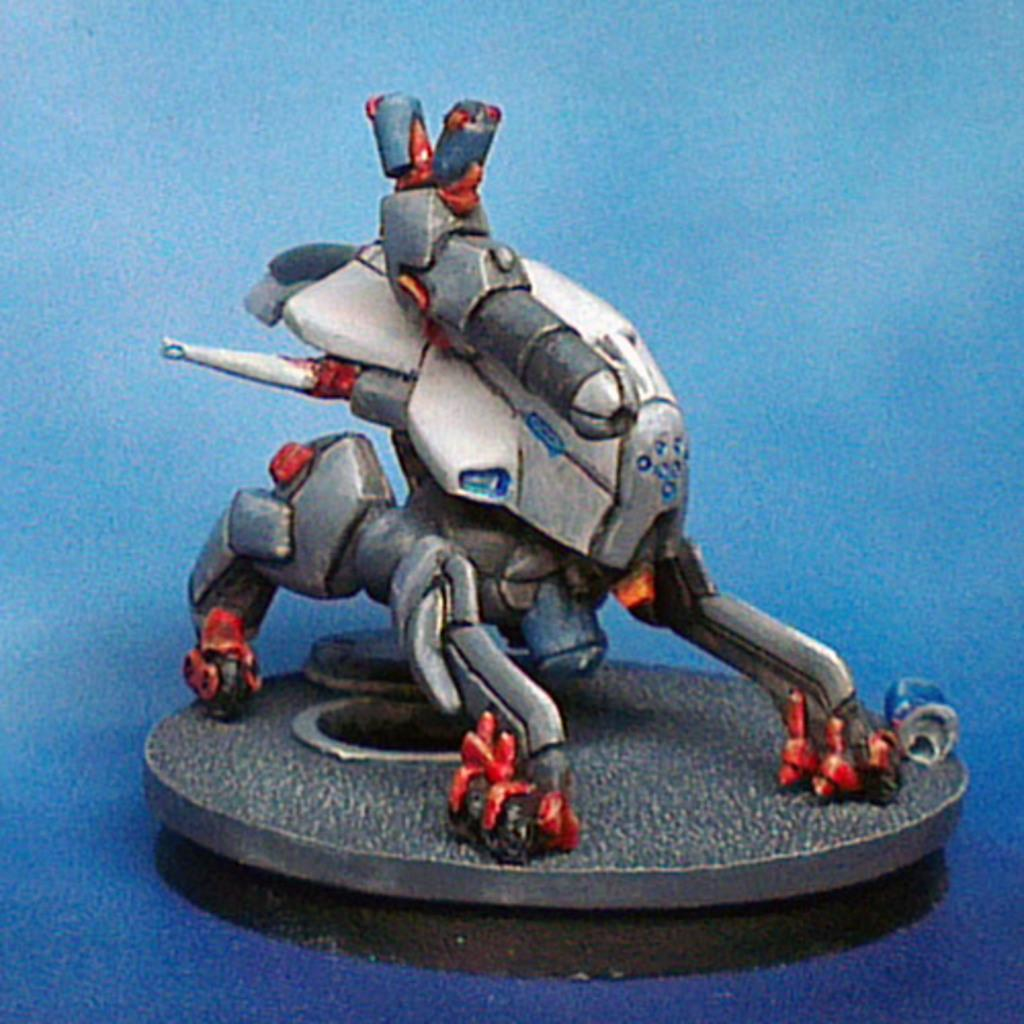What object can be seen in the image? There is a toy in the image. What color is the background of the image? The background of the image is blue. What type of zipper is featured in the scene? There is no zipper present in the image, as it only contains a toy and a blue background. 